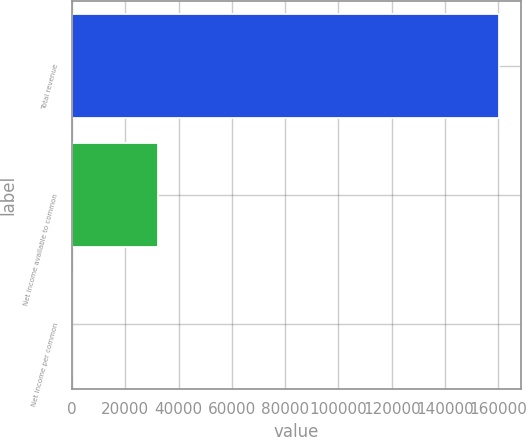Convert chart to OTSL. <chart><loc_0><loc_0><loc_500><loc_500><bar_chart><fcel>Total revenue<fcel>Net income available to common<fcel>Net income per common<nl><fcel>160358<fcel>32071.9<fcel>0.35<nl></chart> 